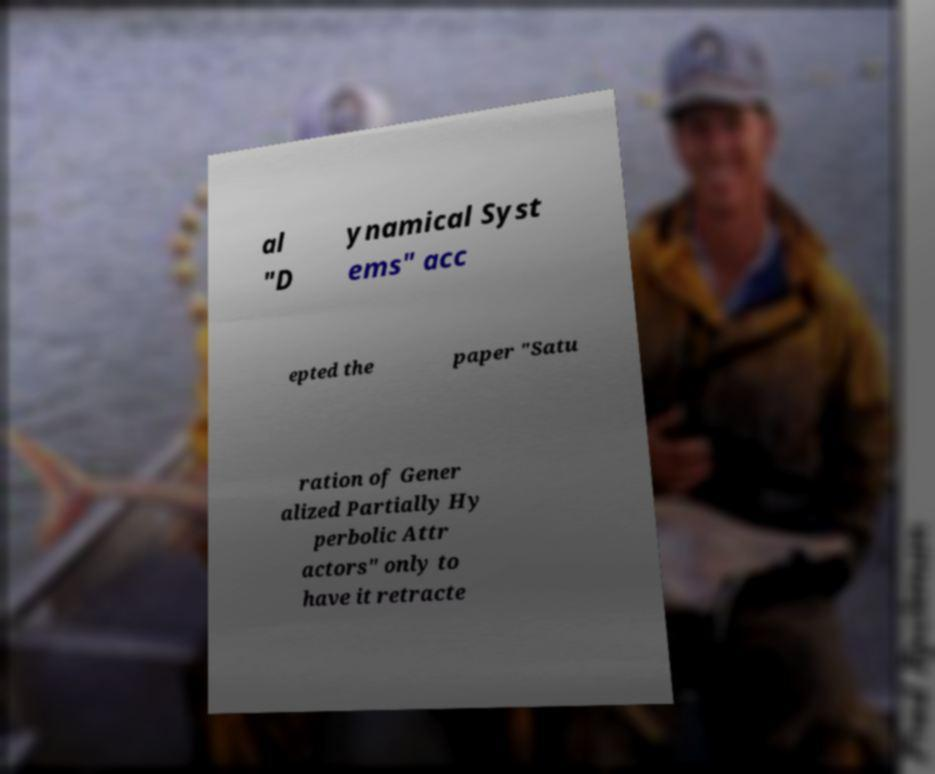Could you assist in decoding the text presented in this image and type it out clearly? al "D ynamical Syst ems" acc epted the paper "Satu ration of Gener alized Partially Hy perbolic Attr actors" only to have it retracte 